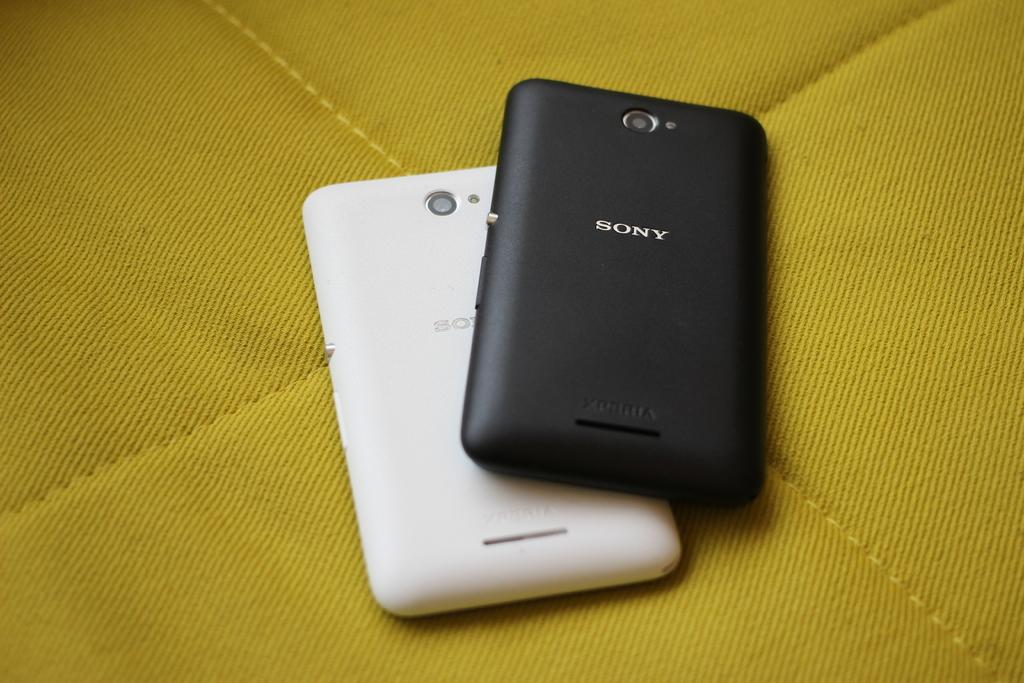<image>
Summarize the visual content of the image. A black Sony phone is laid on top of a white one. 